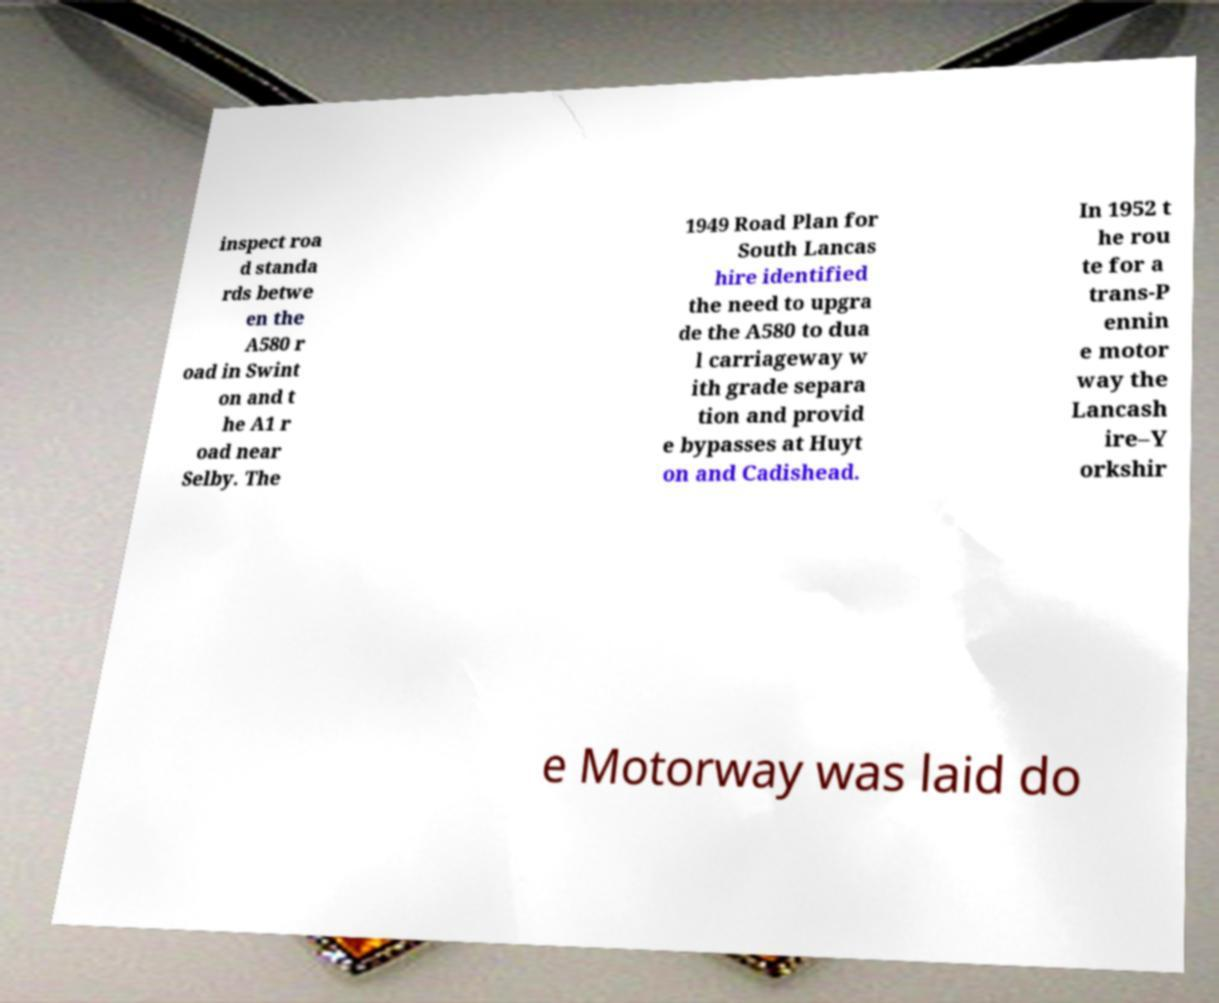For documentation purposes, I need the text within this image transcribed. Could you provide that? inspect roa d standa rds betwe en the A580 r oad in Swint on and t he A1 r oad near Selby. The 1949 Road Plan for South Lancas hire identified the need to upgra de the A580 to dua l carriageway w ith grade separa tion and provid e bypasses at Huyt on and Cadishead. In 1952 t he rou te for a trans-P ennin e motor way the Lancash ire–Y orkshir e Motorway was laid do 